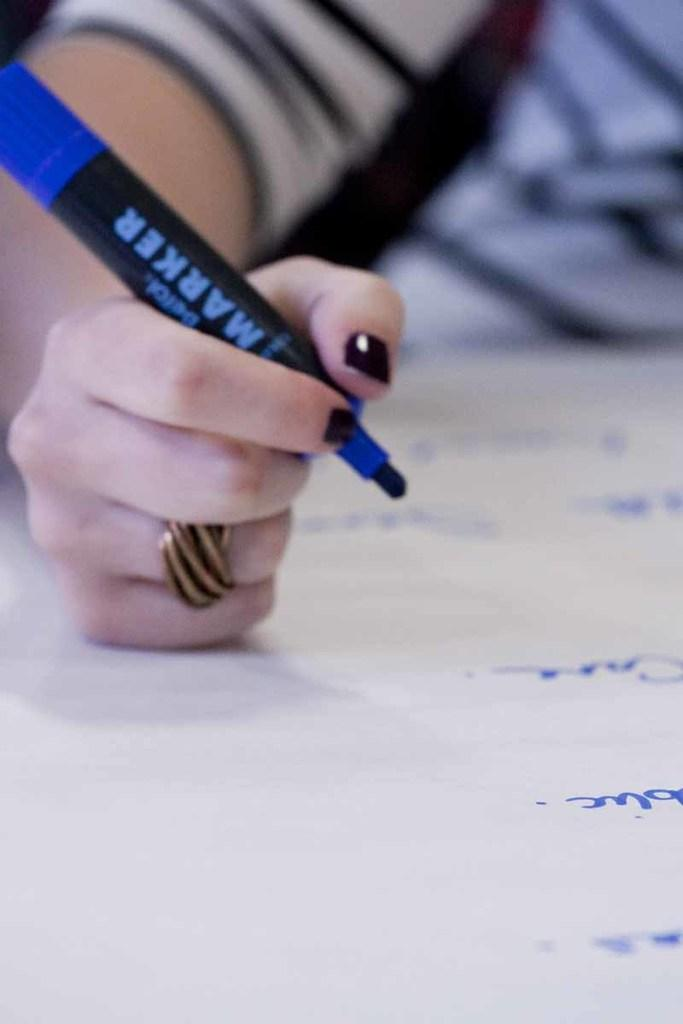What is the main subject of the image? There is a person in the image. What is the person holding in the image? The person is holding a marker. Can you describe any accessories the person is wearing? The person is wearing a ring. What else can be seen in the image besides the person? There is text on a paper in the image. What type of owl can be seen perched on the person's shoulder in the image? There is no owl present in the image; the person is only holding a marker and wearing a ring. What kind of vessel is being used to hold the text on the paper? There is no vessel present in the image; the text is written directly on the paper. 